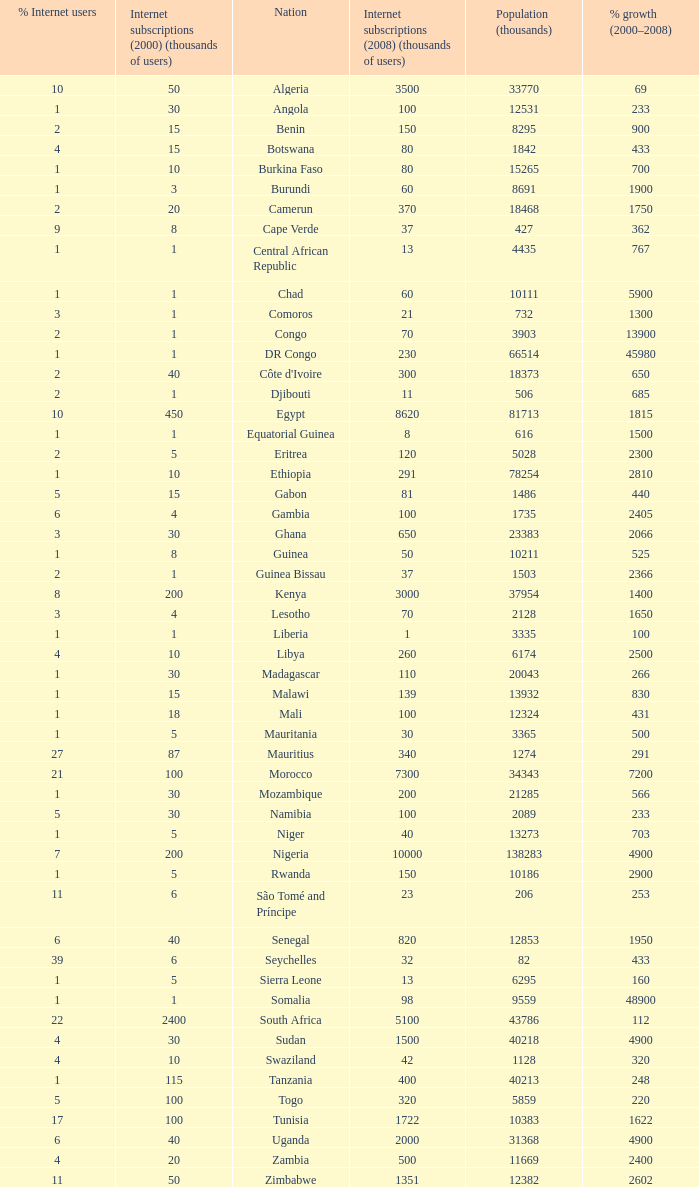What is the maximum percentage grown 2000-2008 in burundi 1900.0. 